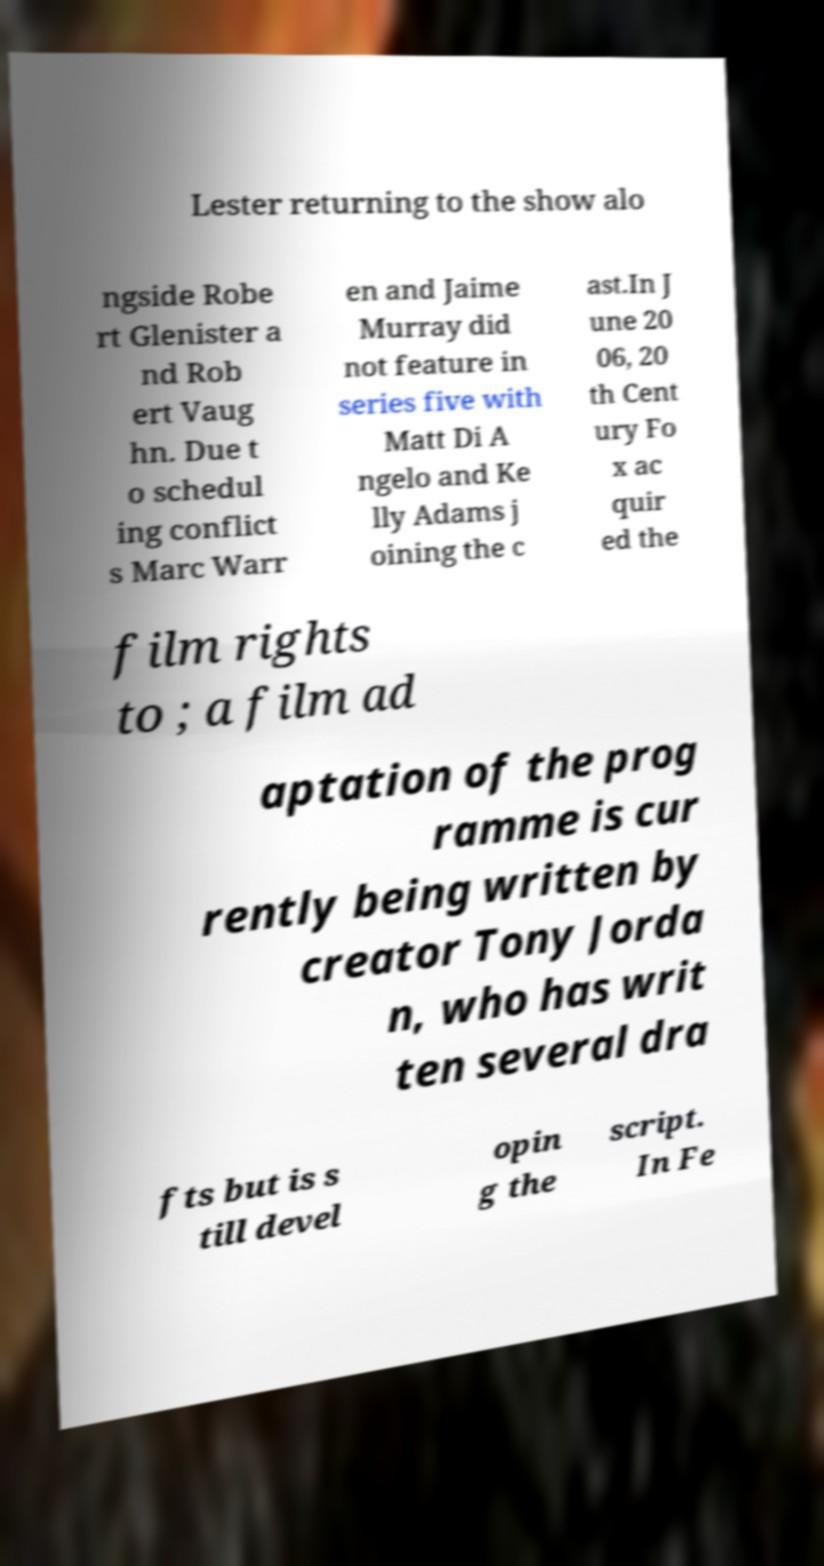Please read and relay the text visible in this image. What does it say? Lester returning to the show alo ngside Robe rt Glenister a nd Rob ert Vaug hn. Due t o schedul ing conflict s Marc Warr en and Jaime Murray did not feature in series five with Matt Di A ngelo and Ke lly Adams j oining the c ast.In J une 20 06, 20 th Cent ury Fo x ac quir ed the film rights to ; a film ad aptation of the prog ramme is cur rently being written by creator Tony Jorda n, who has writ ten several dra fts but is s till devel opin g the script. In Fe 